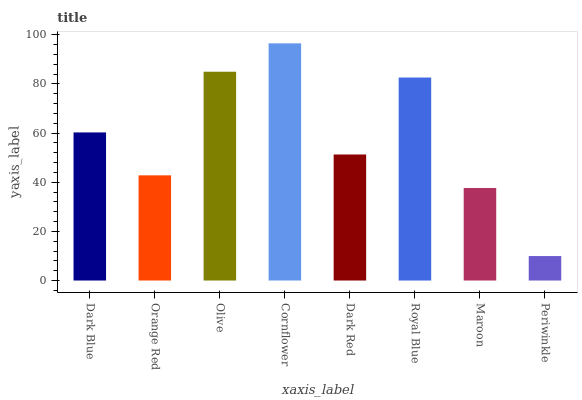Is Periwinkle the minimum?
Answer yes or no. Yes. Is Cornflower the maximum?
Answer yes or no. Yes. Is Orange Red the minimum?
Answer yes or no. No. Is Orange Red the maximum?
Answer yes or no. No. Is Dark Blue greater than Orange Red?
Answer yes or no. Yes. Is Orange Red less than Dark Blue?
Answer yes or no. Yes. Is Orange Red greater than Dark Blue?
Answer yes or no. No. Is Dark Blue less than Orange Red?
Answer yes or no. No. Is Dark Blue the high median?
Answer yes or no. Yes. Is Dark Red the low median?
Answer yes or no. Yes. Is Royal Blue the high median?
Answer yes or no. No. Is Royal Blue the low median?
Answer yes or no. No. 